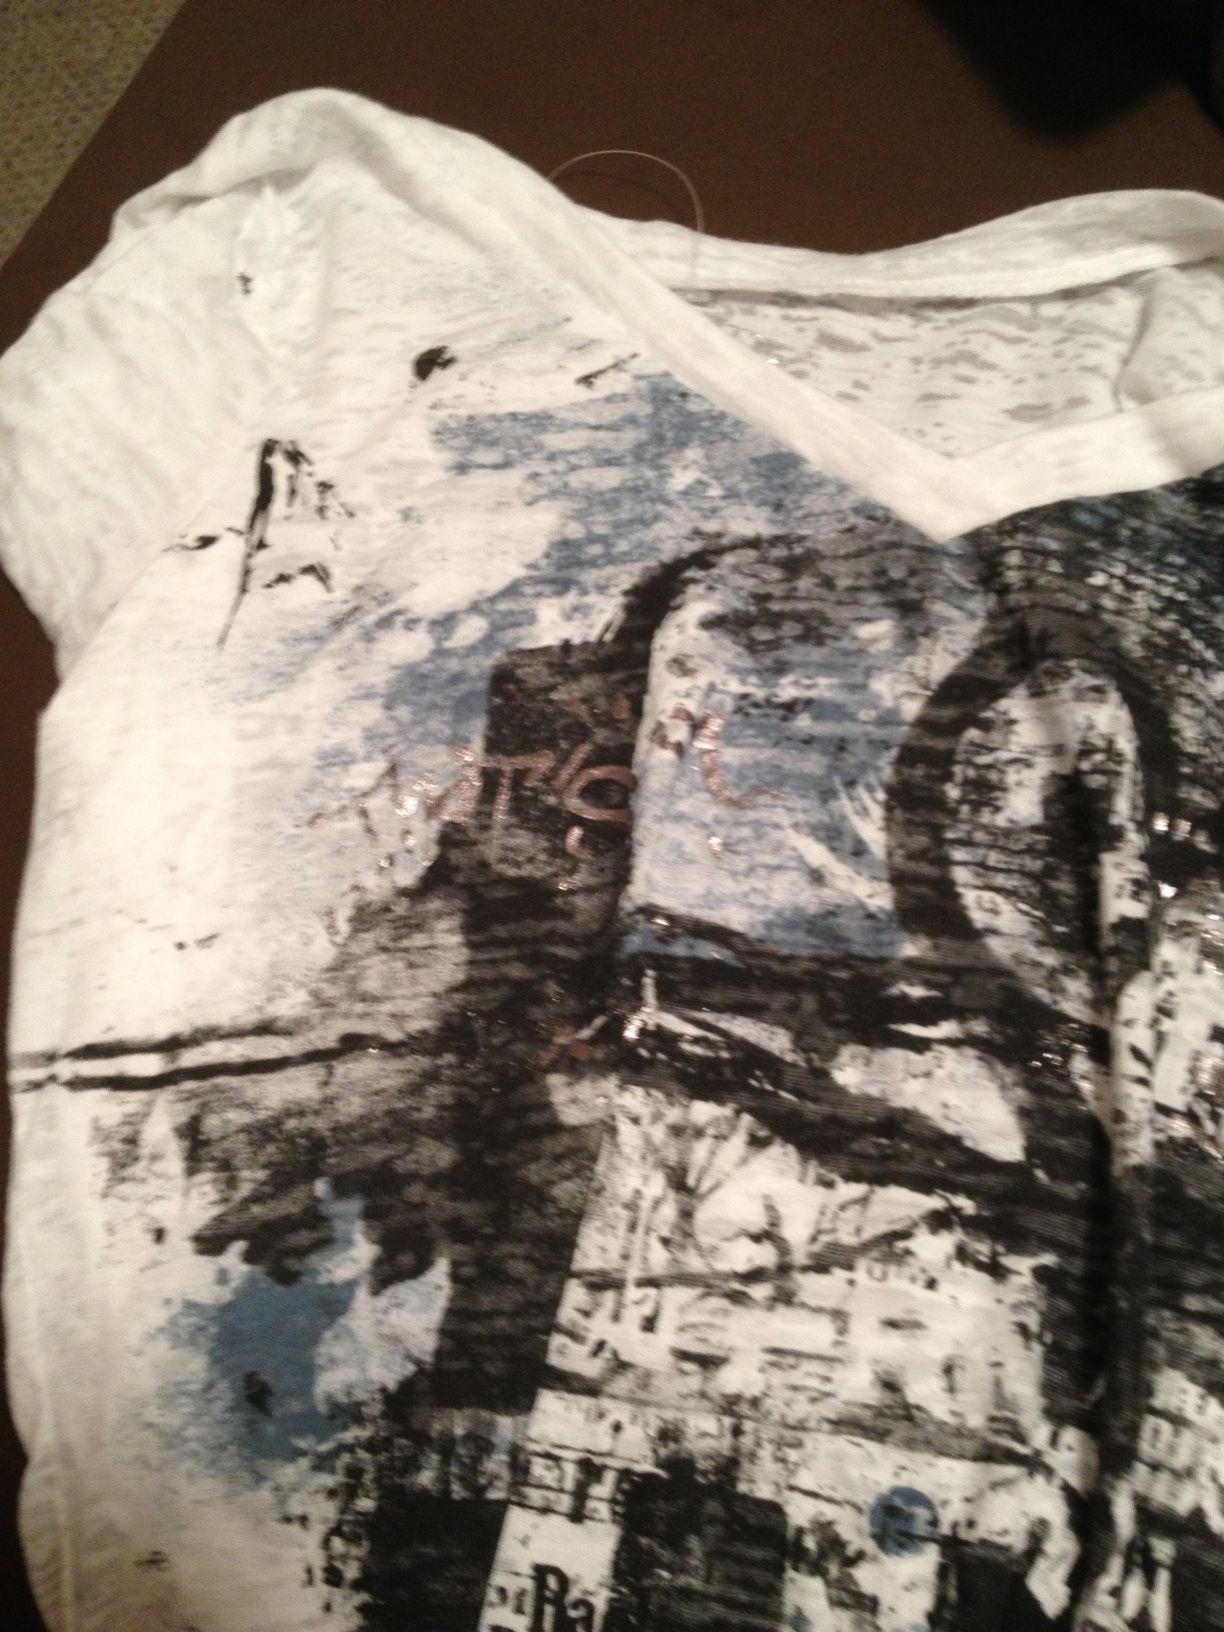Imagine that the design on this shirt is part of a larger canvas. Describe what the full artwork might look like. The full artwork would likely be an expansive abstract piece stretching over a large canvas. It would feature a chaotic yet captivating mix of colors and textures, with bold black strokes providing a dramatic contrast to softer blue and white areas. The intricate layering would create a sense of depth and movement, drawing the viewer in to explore the complexities of the design. Scattered across the composition, there might be fragments of words or symbols, partially obscured yet hinting at deeper meanings or messages hidden within the art. What kind of message do you think the artist is trying to convey with this design? The artist could be trying to convey the beauty in chaos, where seemingly random elements come together to create something visually compelling. The partial words and symbols might hint at themes of communication and the fragmentation of thought, urging the viewer to find meaning in the abstract. It reflects the complexity of human emotions and experiences, symbolizing how they intertwine and overlap in unpredictable ways. 